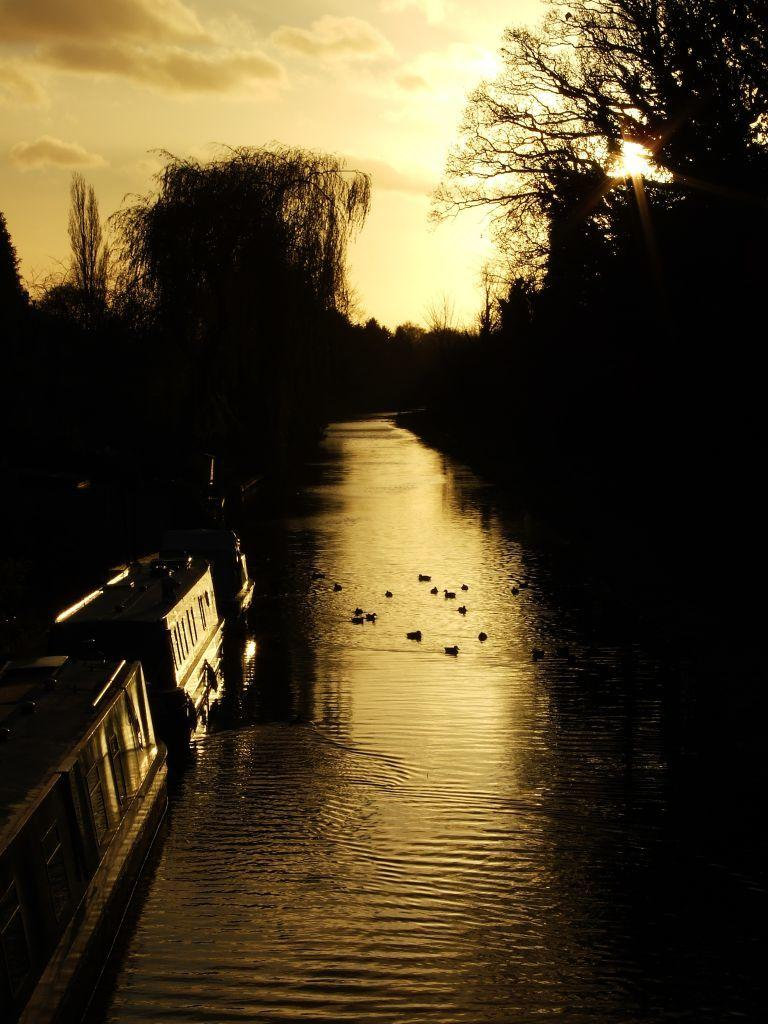What type of water feature is present in the image? There is a canal in the image. What surrounds the canal in the image? The canal is situated between trees. Can you describe the object in the bottom left of the image? Unfortunately, the facts provided do not give any information about the object in the bottom left of the image. What is visible at the top of the image? The sky is visible at the top of the image. How many icicles are hanging from the trees in the image? There are no icicles present in the image; it features a canal situated between trees. Can you describe the kiss between the two people in the image? There are no people or kisses present in the image; it features a canal situated between trees. 